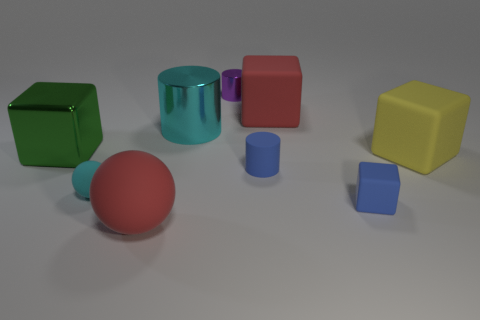Subtract all large red blocks. How many blocks are left? 3 Subtract all blue blocks. How many blocks are left? 3 Subtract 1 cylinders. How many cylinders are left? 2 Subtract all gray blocks. Subtract all cyan spheres. How many blocks are left? 4 Add 4 red matte spheres. How many red matte spheres exist? 5 Subtract 1 blue cylinders. How many objects are left? 8 Subtract all blocks. How many objects are left? 5 Subtract all large green metallic blocks. Subtract all cylinders. How many objects are left? 5 Add 4 cyan matte objects. How many cyan matte objects are left? 5 